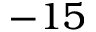<formula> <loc_0><loc_0><loc_500><loc_500>- 1 5</formula> 